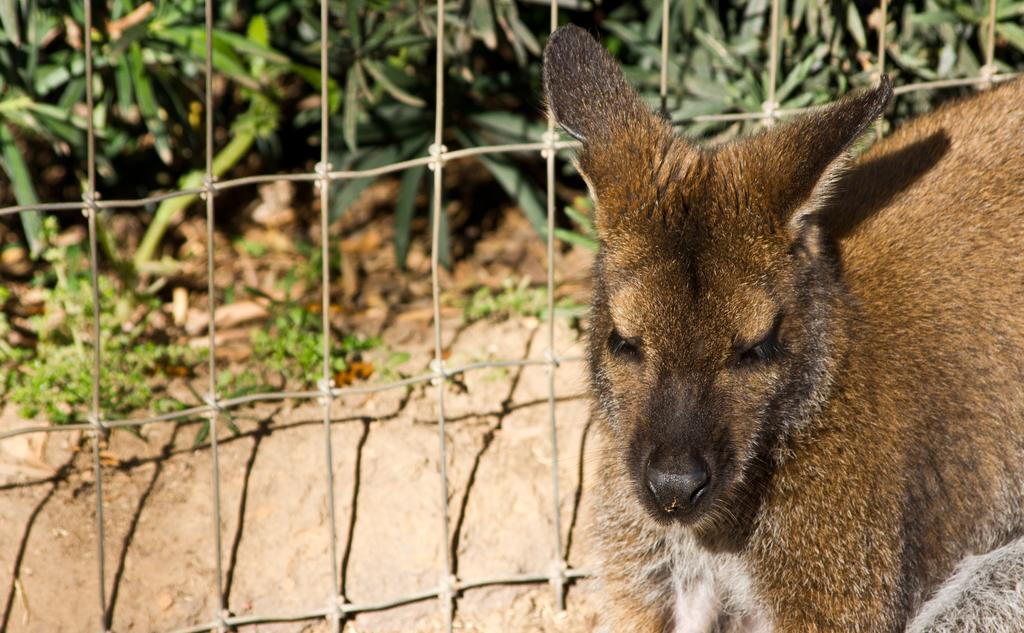What type of living creature is in the picture? There is an animal in the picture. What is the animal near or behind? There is a fence in the picture. What can be seen in the distance in the picture? Plants are visible in the background of the picture. What does the animal's mom say about the fence in the picture? There is no indication in the image that the animal has a mom, nor is there any dialogue or commentary about the fence. 